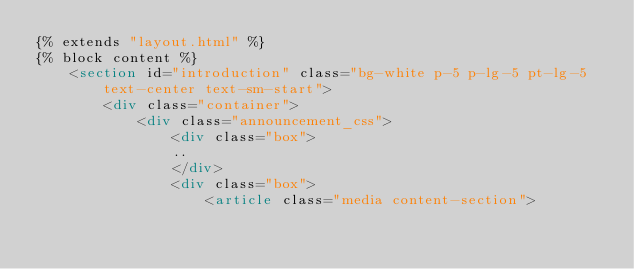<code> <loc_0><loc_0><loc_500><loc_500><_HTML_>{% extends "layout.html" %}
{% block content %}
    <section id="introduction" class="bg-white p-5 p-lg-5 pt-lg-5 text-center text-sm-start">
        <div class="container">
            <div class="announcement_css">
                <div class="box">
                ..
                </div>
                <div class="box">
                    <article class="media content-section"></code> 